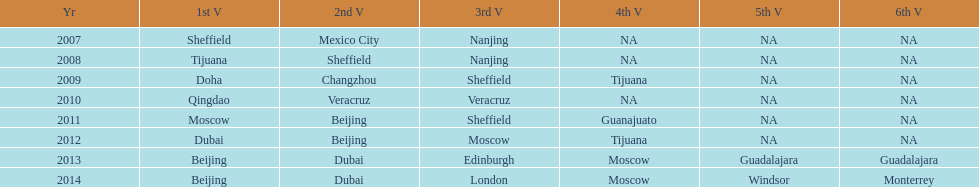Which year had more venues, 2007 or 2012? 2012. 